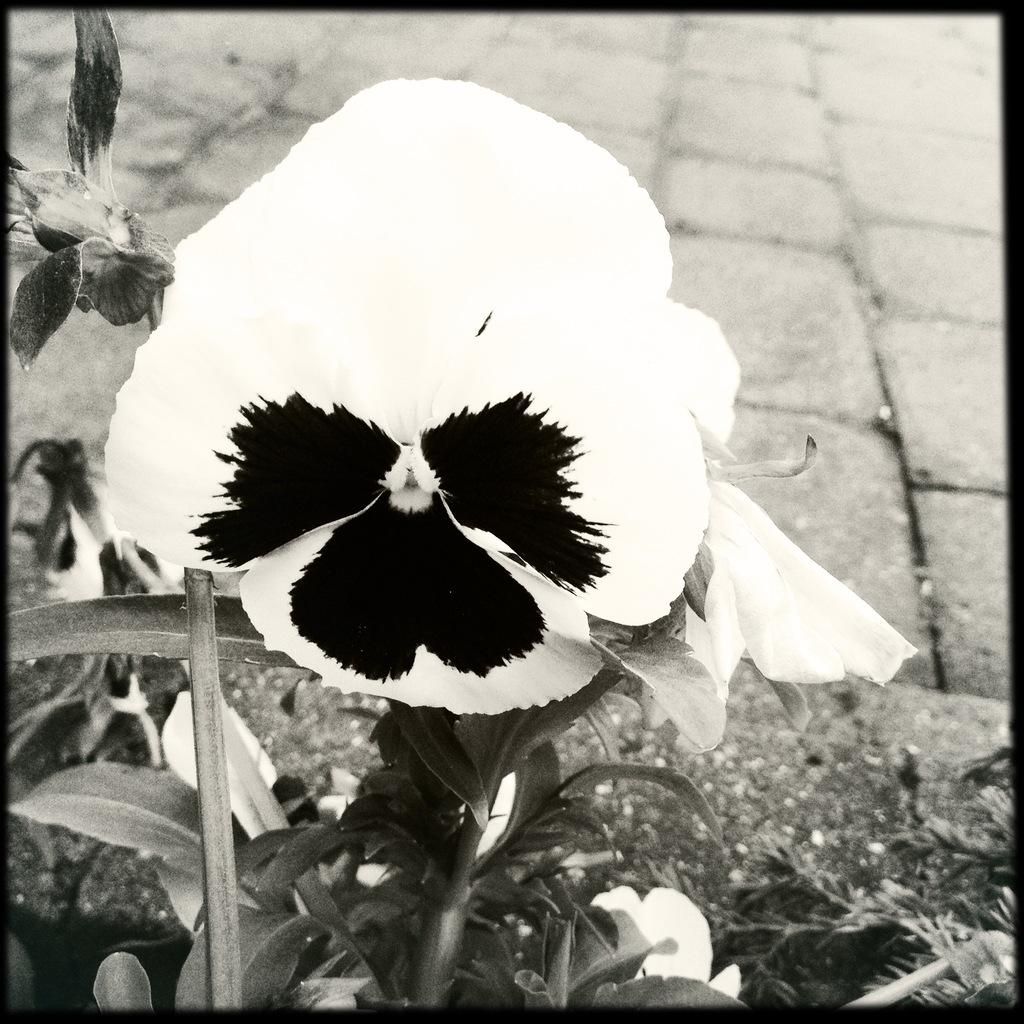What type of plant can be seen in the image? There is a flower in the image. Are there any other parts of the plant visible besides the flower? Yes, there are leaves in the image. What is the color scheme of the image? The image is black and white. How many matches are visible in the image? There are no matches present in the image. What type of animal can be seen in the image? There is no animal, such as a giraffe, present in the image. 